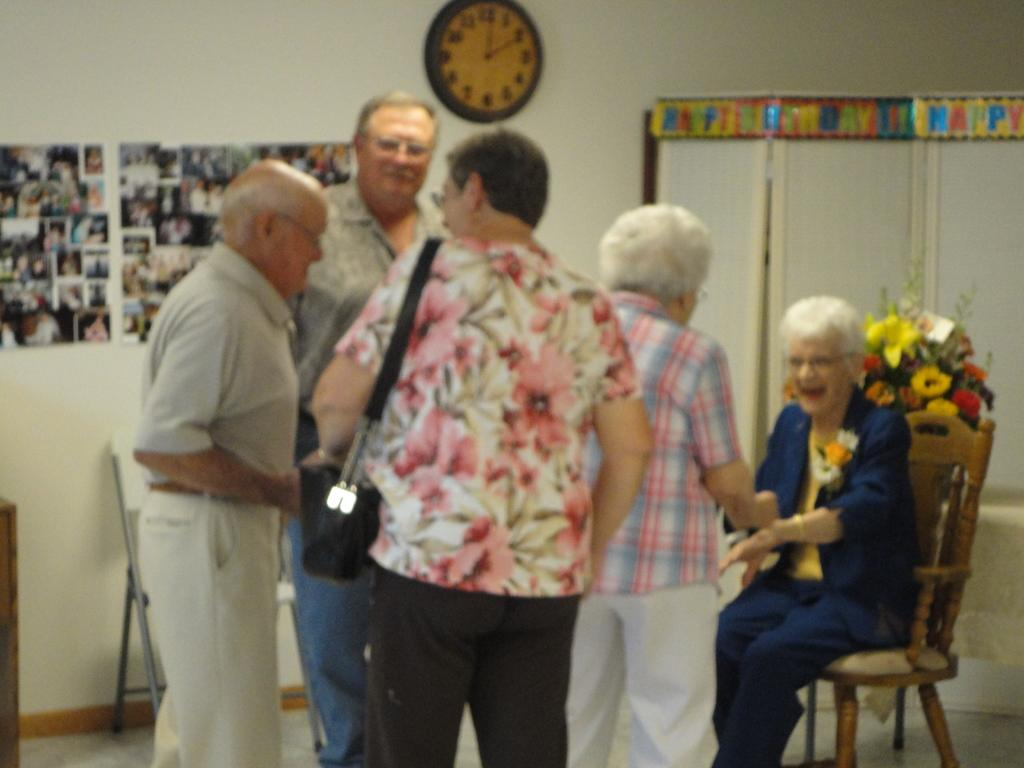<image>
Present a compact description of the photo's key features. A happy birthday banner is behind five people. 